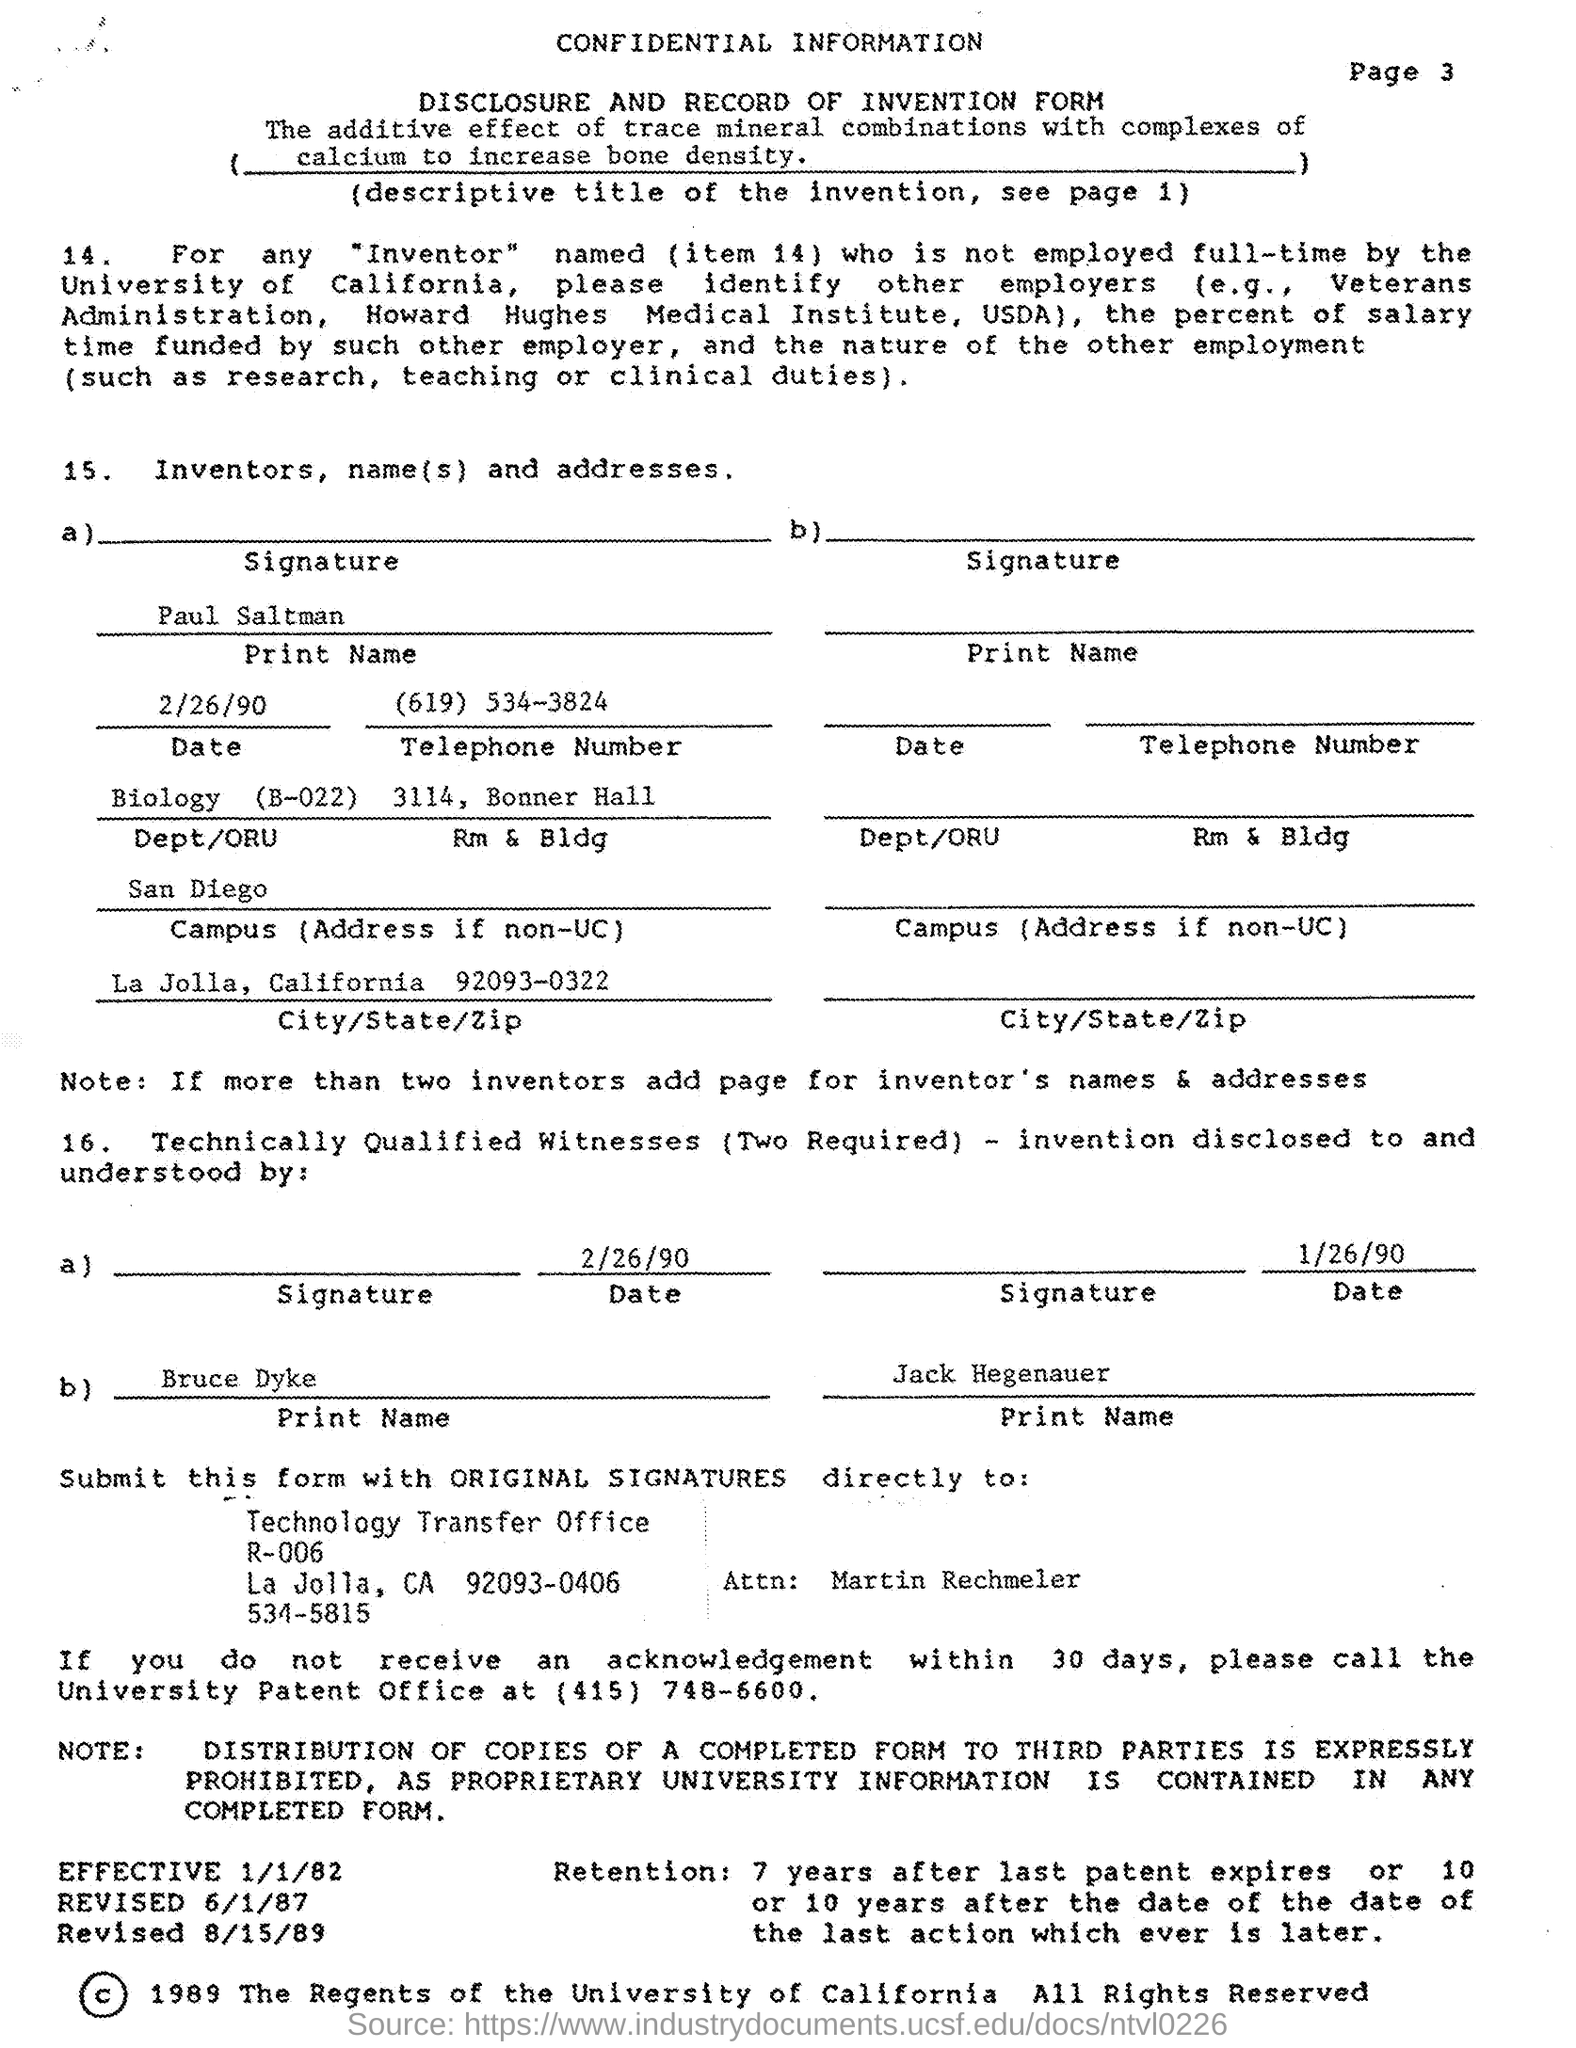What is the telephone number mentioned in the given form ?
Give a very brief answer. (619) 534-3824. What is the dept/oru mentioned in the given form ?
Offer a terse response. Biology (B-022). What is the name of the campus mentioned in the given form ?
Provide a succinct answer. San Diego. What is the city mentioned in the given form ?
Your answer should be very brief. La Jolla. What is the state mentioned in the given form ?
Give a very brief answer. California. What is the zip number mentioned in the given form ?
Your response must be concise. 92093-0322. 